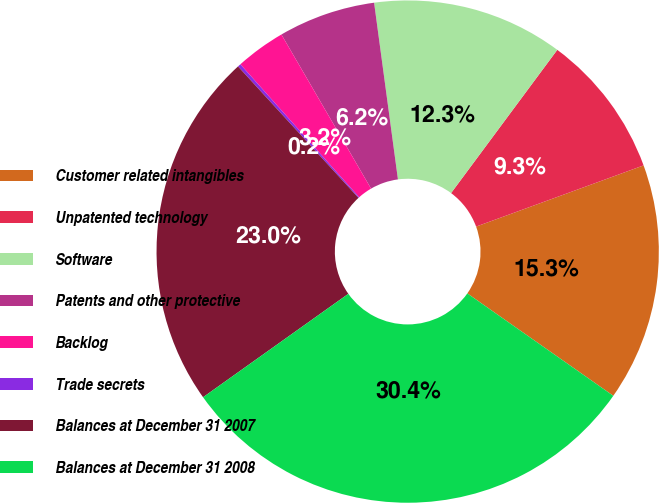Convert chart to OTSL. <chart><loc_0><loc_0><loc_500><loc_500><pie_chart><fcel>Customer related intangibles<fcel>Unpatented technology<fcel>Software<fcel>Patents and other protective<fcel>Backlog<fcel>Trade secrets<fcel>Balances at December 31 2007<fcel>Balances at December 31 2008<nl><fcel>15.31%<fcel>9.27%<fcel>12.29%<fcel>6.25%<fcel>3.22%<fcel>0.2%<fcel>23.04%<fcel>30.42%<nl></chart> 